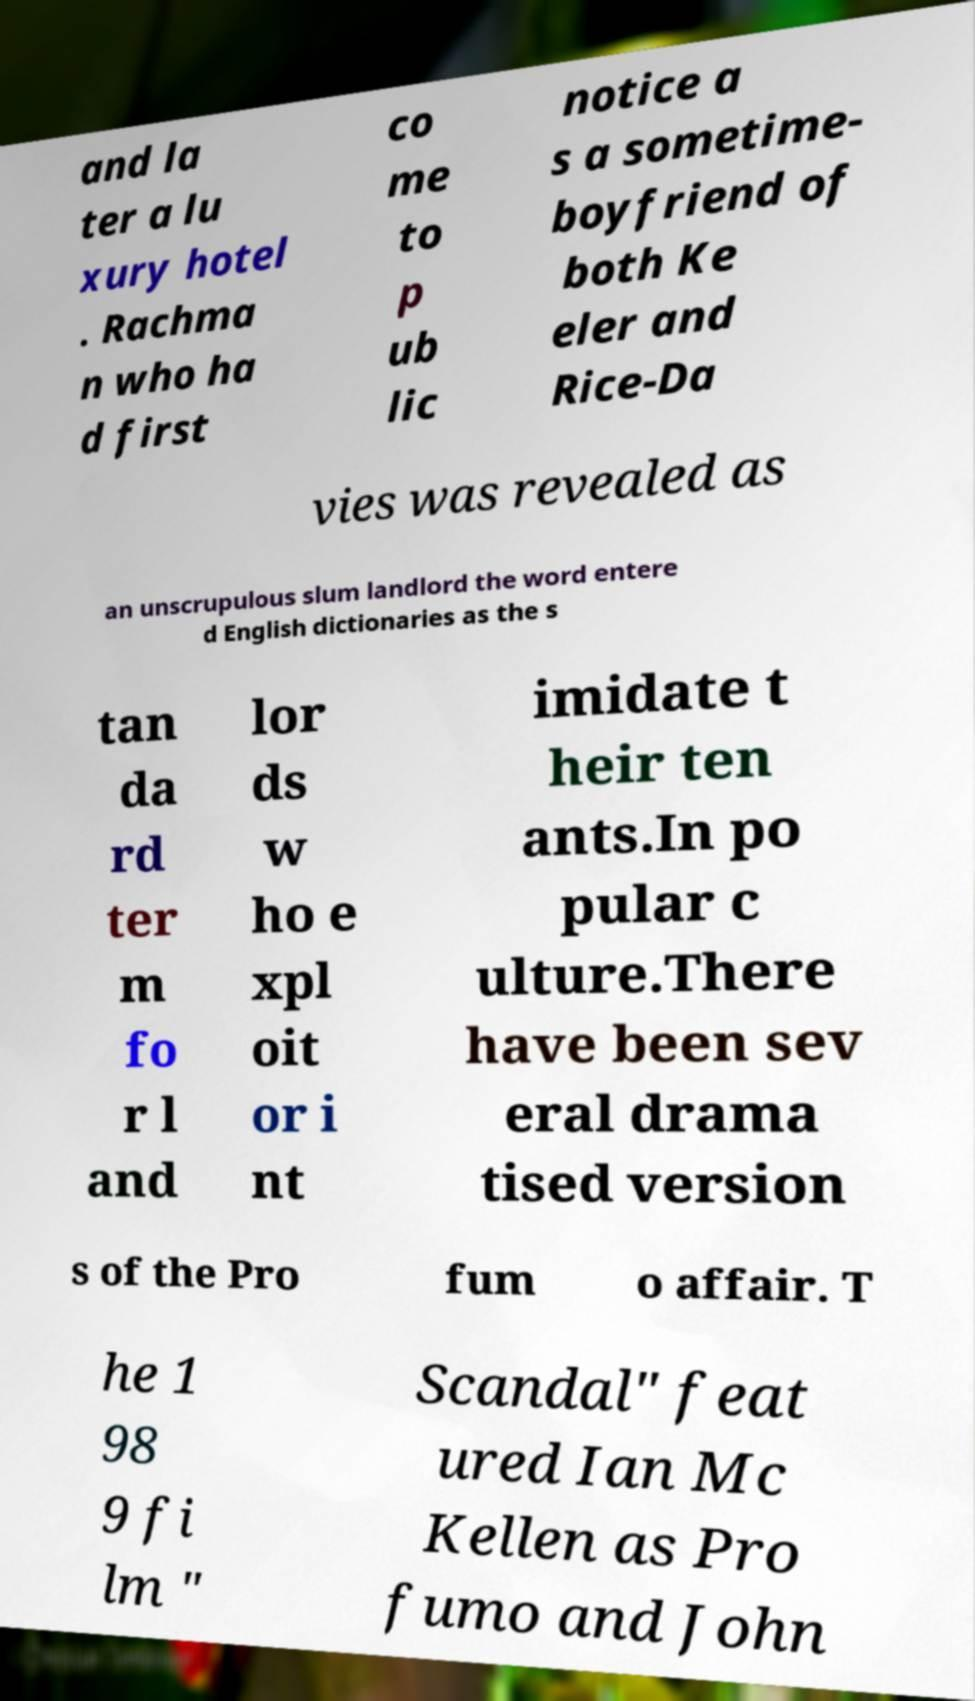I need the written content from this picture converted into text. Can you do that? and la ter a lu xury hotel . Rachma n who ha d first co me to p ub lic notice a s a sometime- boyfriend of both Ke eler and Rice-Da vies was revealed as an unscrupulous slum landlord the word entere d English dictionaries as the s tan da rd ter m fo r l and lor ds w ho e xpl oit or i nt imidate t heir ten ants.In po pular c ulture.There have been sev eral drama tised version s of the Pro fum o affair. T he 1 98 9 fi lm " Scandal" feat ured Ian Mc Kellen as Pro fumo and John 